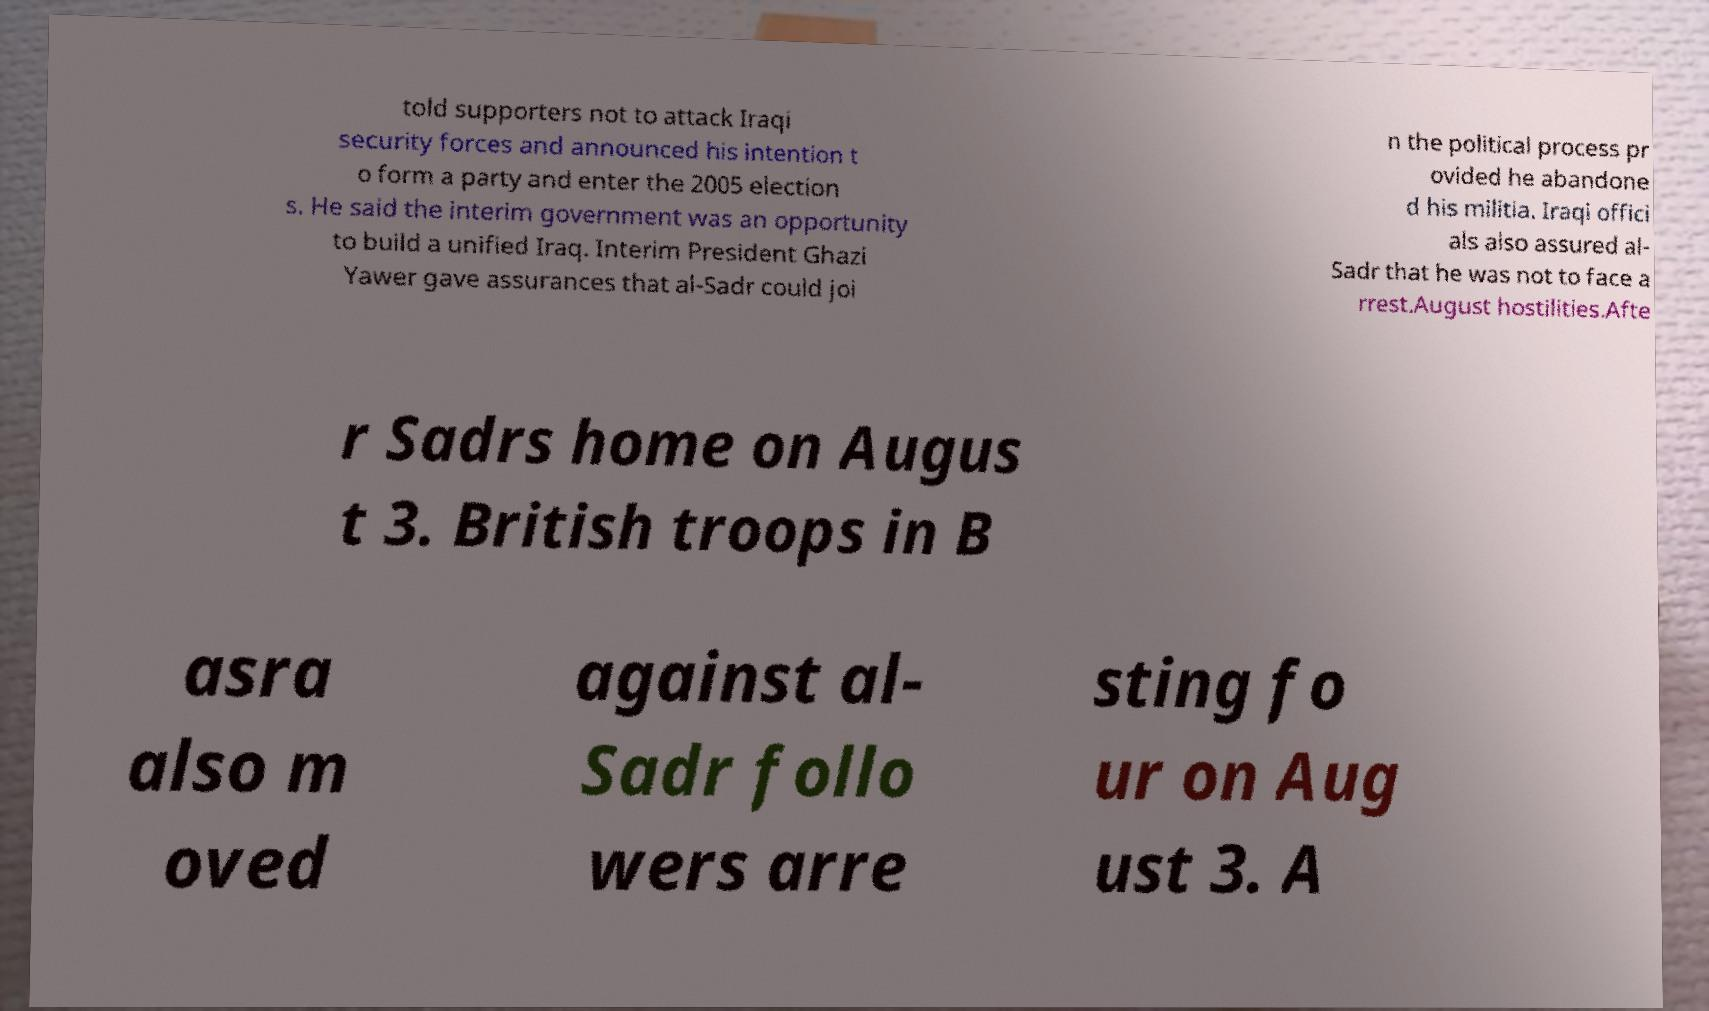Please identify and transcribe the text found in this image. told supporters not to attack Iraqi security forces and announced his intention t o form a party and enter the 2005 election s. He said the interim government was an opportunity to build a unified Iraq. Interim President Ghazi Yawer gave assurances that al-Sadr could joi n the political process pr ovided he abandone d his militia. Iraqi offici als also assured al- Sadr that he was not to face a rrest.August hostilities.Afte r Sadrs home on Augus t 3. British troops in B asra also m oved against al- Sadr follo wers arre sting fo ur on Aug ust 3. A 